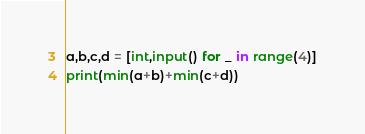Convert code to text. <code><loc_0><loc_0><loc_500><loc_500><_Python_>a,b,c,d = [int,input() for _ in range(4)]
print(min(a+b)+min(c+d))</code> 